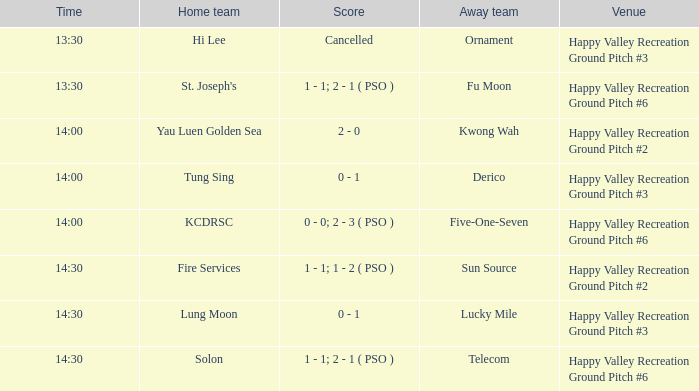What is the home team when kwong wah was the away team? Yau Luen Golden Sea. 